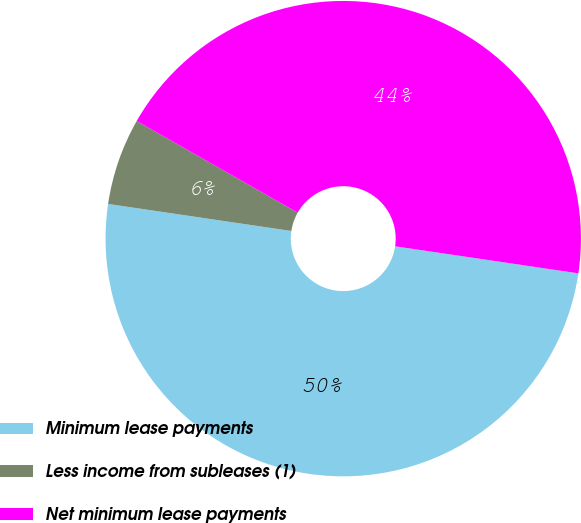Convert chart. <chart><loc_0><loc_0><loc_500><loc_500><pie_chart><fcel>Minimum lease payments<fcel>Less income from subleases (1)<fcel>Net minimum lease payments<nl><fcel>50.0%<fcel>5.91%<fcel>44.09%<nl></chart> 